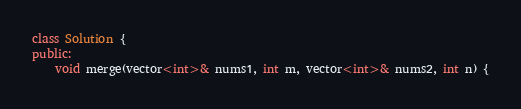Convert code to text. <code><loc_0><loc_0><loc_500><loc_500><_C++_>class Solution {
public:
    void merge(vector<int>& nums1, int m, vector<int>& nums2, int n) {</code> 